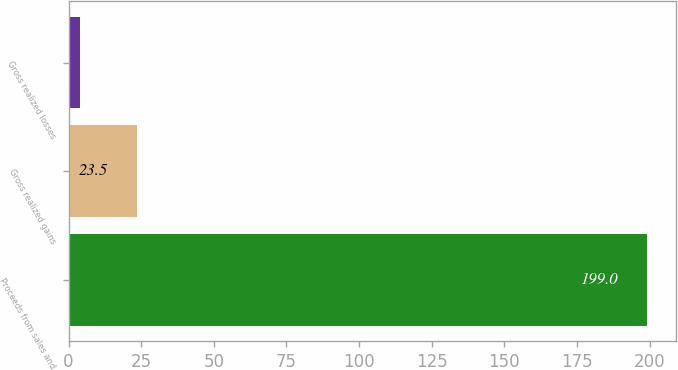Convert chart to OTSL. <chart><loc_0><loc_0><loc_500><loc_500><bar_chart><fcel>Proceeds from sales and<fcel>Gross realized gains<fcel>Gross realized losses<nl><fcel>199<fcel>23.5<fcel>4<nl></chart> 